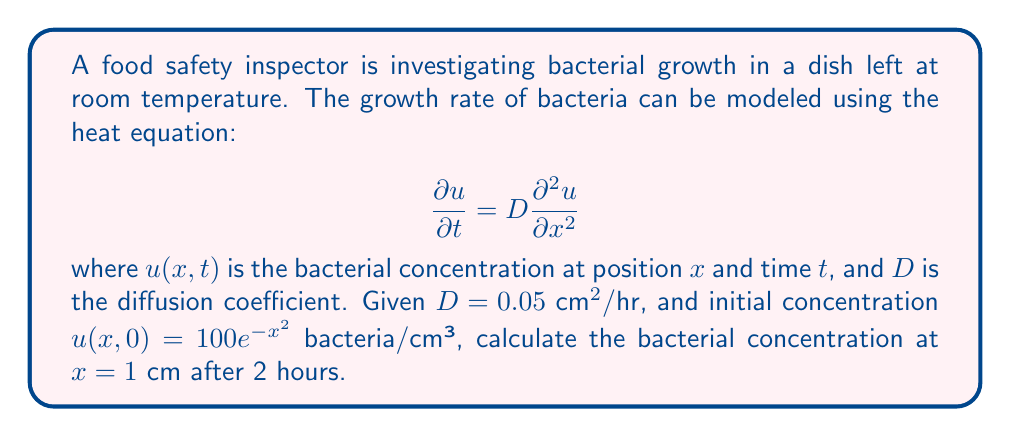Can you answer this question? To solve this problem, we'll use the fundamental solution of the heat equation:

$$u(x,t) = \frac{1}{\sqrt{4\pi Dt}} \int_{-\infty}^{\infty} u(\xi,0) e^{-\frac{(x-\xi)^2}{4Dt}} d\xi$$

Step 1: Substitute the given values:
$D = 0.05 \text{ cm}^2/\text{hr}$, $t = 2 \text{ hr}$, $x = 1 \text{ cm}$, $u(\xi,0) = 100e^{-\xi^2}$

Step 2: Calculate the coefficient:
$$\frac{1}{\sqrt{4\pi Dt}} = \frac{1}{\sqrt{4\pi(0.05)(2)}} = \frac{1}{\sqrt{0.4\pi}} \approx 0.8905$$

Step 3: Set up the integral:
$$u(1,2) = 0.8905 \int_{-\infty}^{\infty} 100e^{-\xi^2} e^{-\frac{(1-\xi)^2}{4(0.05)(2)}} d\xi$$

Step 4: Simplify the exponent in the integrand:
$$u(1,2) = 89.05 \int_{-\infty}^{\infty} e^{-\xi^2 - \frac{(1-\xi)^2}{0.4}} d\xi$$
$$= 89.05 \int_{-\infty}^{\infty} e^{-\xi^2 - \frac{1-2\xi+\xi^2}{0.4}} d\xi$$
$$= 89.05 \int_{-\infty}^{\infty} e^{-1.4\xi^2 + 5\xi - 2.5} d\xi$$

Step 5: Complete the square in the exponent:
$$u(1,2) = 89.05 e^{-2.5} \int_{-\infty}^{\infty} e^{-1.4(\xi^2 - \frac{5}{1.4}\xi + (\frac{5}{2.8})^2 - (\frac{5}{2.8})^2)} d\xi$$
$$= 89.05 e^{-2.5} e^{\frac{25}{5.6}} \int_{-\infty}^{\infty} e^{-1.4(\xi - \frac{5}{2.8})^2} d\xi$$

Step 6: Evaluate the integral:
$$u(1,2) = 89.05 e^{-2.5} e^{\frac{25}{5.6}} \sqrt{\frac{\pi}{1.4}}$$

Step 7: Calculate the final result:
$$u(1,2) \approx 32.88 \text{ bacteria/cm³}$$
Answer: 32.88 bacteria/cm³ 